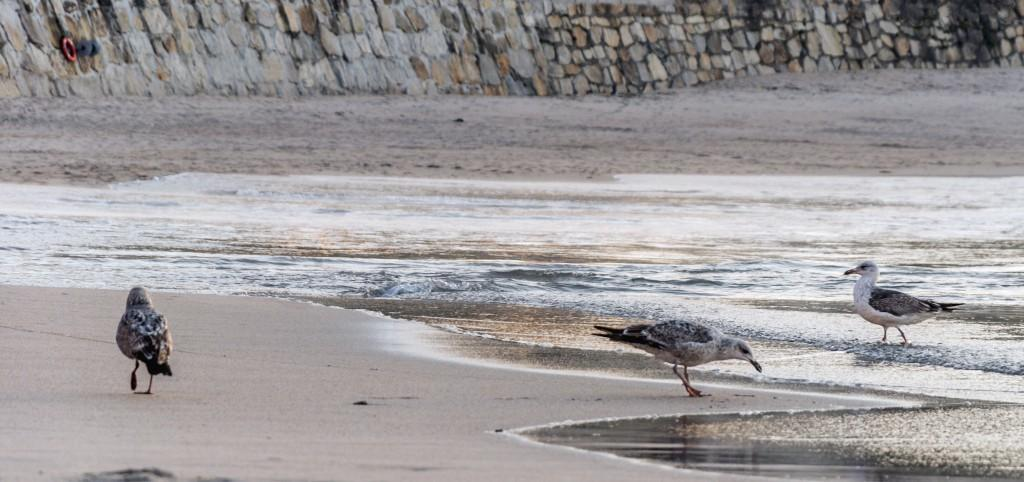How many birds are present in the image? There are three birds in the image. Where are two of the birds located? Two of the birds are on the ground. What is the location of the third bird? The third bird is in the water. What can be seen in the background of the image? There is a wall visible in the background of the image. What is the limit of the bird's ability to shake in the image? There is no indication in the image of the bird shaking or any limitations related to shaking. 